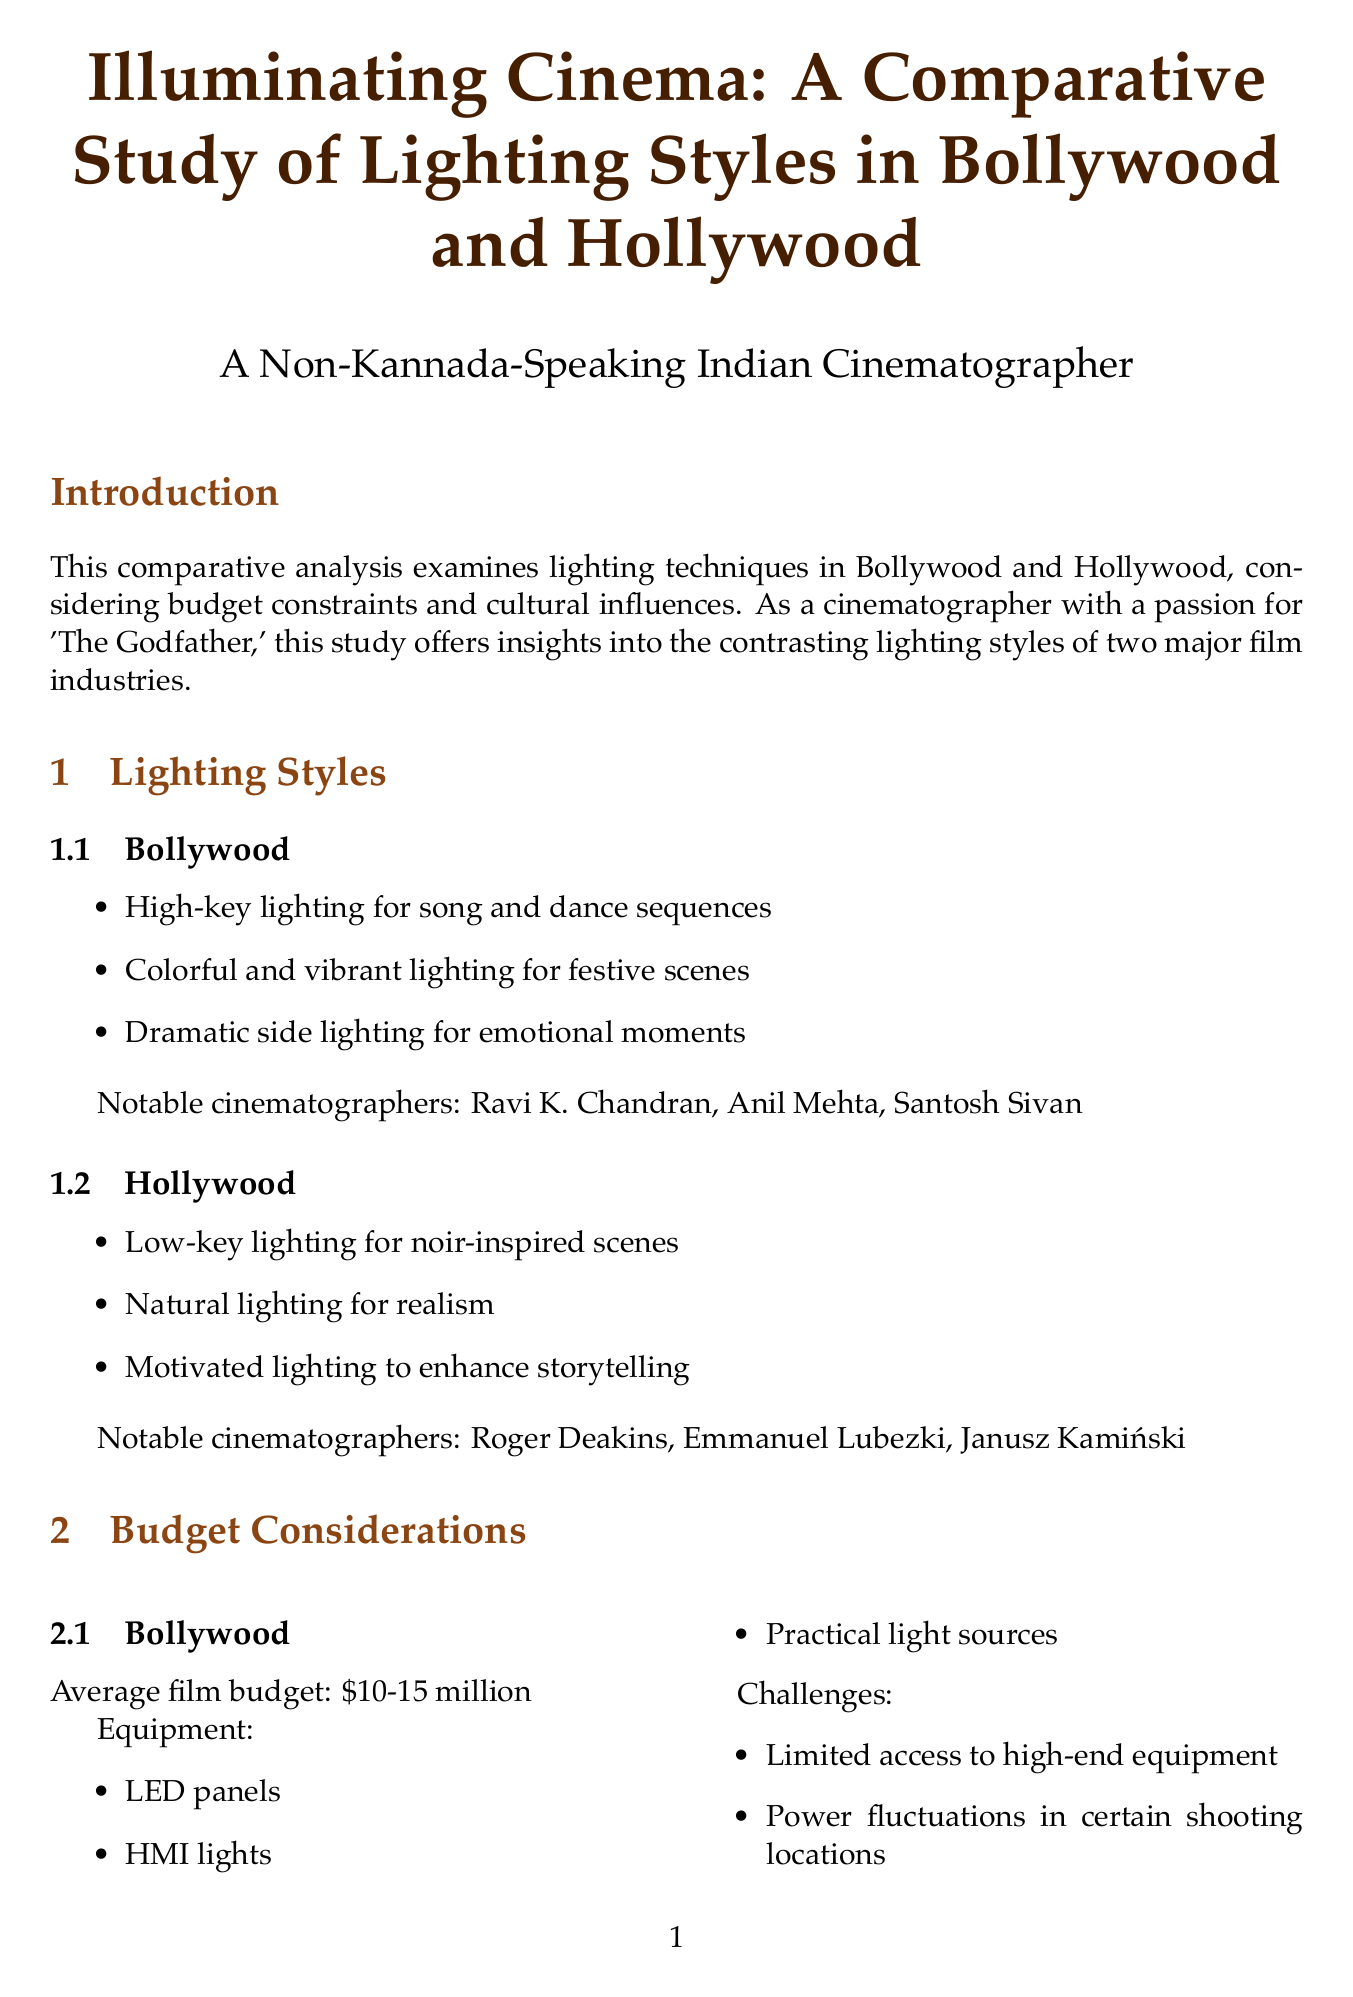What are common lighting techniques in Bollywood? Bollywood's common lighting techniques include high-key lighting for song sequences, colorful vibrant lighting for festive scenes, and dramatic side lighting for emotional moments.
Answer: High-key, colorful, dramatic side What is the average film budget in Bollywood? The average film budget in Bollywood is specified in the document, indicating the financial scope filmmakers work within.
Answer: $10-15 million Who is the cinematographer of "The Godfather"? The document mentions notable cinematographers for different films, including "The Godfather."
Answer: Gordon Willis What is a key difference between Bollywood and Hollywood lighting styles? The document outlines the contrasting approaches to lighting styles between the two industries, indicating how each influences visual storytelling.
Answer: Brightness and color Which lighting technique is commonly used in Hollywood for thrillers? The document specifies Hollywood's preferences for specific genres, helping to identify essential lighting styles for different film types.
Answer: Realistic lighting What technology trend is noted for impact on lighting in both industries? The document outlines advancements in technology affecting the lighting practices in cinema, indicating a broader trend within the film industry.
Answer: LED technology What type of lighting is used for family confrontations in Bollywood? The document describes specific storytelling elements related to lighting, helping to illustrate how emotional situations are visually conveyed.
Answer: Dramatic lighting Name a notable cinematographer in Hollywood. The document lists notable cinematographers associated with Hollywood films, providing insights into influential figures in that industry.
Answer: Roger Deakins What are the aesthetic preferences mentioned for Hollywood? The document explores the aesthetic choices made by Hollywood filmmakers, emphasizing their emphasis on realism and stylization.
Answer: Realistic, stylized, high-contrast 